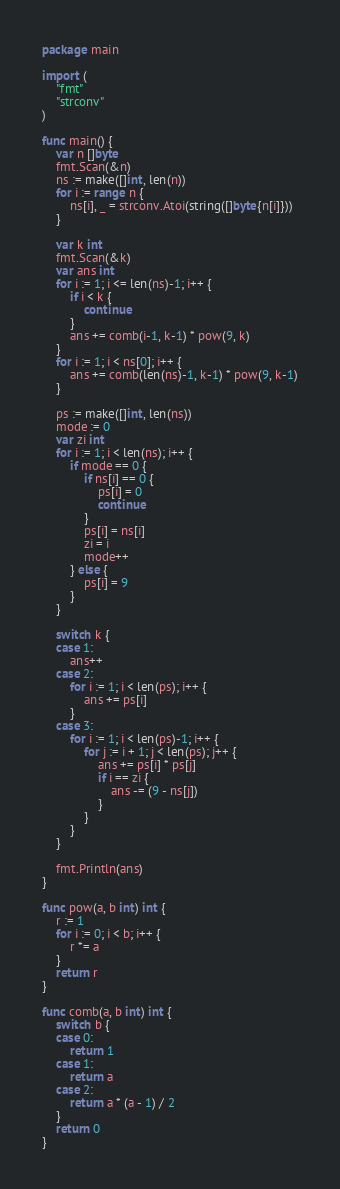Convert code to text. <code><loc_0><loc_0><loc_500><loc_500><_Go_>package main

import (
	"fmt"
	"strconv"
)

func main() {
	var n []byte
	fmt.Scan(&n)
	ns := make([]int, len(n))
	for i := range n {
		ns[i], _ = strconv.Atoi(string([]byte{n[i]}))
	}

	var k int
	fmt.Scan(&k)
	var ans int
	for i := 1; i <= len(ns)-1; i++ {
		if i < k {
			continue
		}
		ans += comb(i-1, k-1) * pow(9, k)
	}
	for i := 1; i < ns[0]; i++ {
		ans += comb(len(ns)-1, k-1) * pow(9, k-1)
	}

	ps := make([]int, len(ns))
	mode := 0
	var zi int
	for i := 1; i < len(ns); i++ {
		if mode == 0 {
			if ns[i] == 0 {
				ps[i] = 0
				continue
			}
			ps[i] = ns[i]
			zi = i
			mode++
		} else {
			ps[i] = 9
		}
	}

	switch k {
	case 1:
		ans++
	case 2:
		for i := 1; i < len(ps); i++ {
			ans += ps[i]
		}
	case 3:
		for i := 1; i < len(ps)-1; i++ {
			for j := i + 1; j < len(ps); j++ {
				ans += ps[i] * ps[j]
				if i == zi {
					ans -= (9 - ns[j])
				}
			}
		}
	}

	fmt.Println(ans)
}

func pow(a, b int) int {
	r := 1
	for i := 0; i < b; i++ {
		r *= a
	}
	return r
}

func comb(a, b int) int {
	switch b {
	case 0:
		return 1
	case 1:
		return a
	case 2:
		return a * (a - 1) / 2
	}
	return 0
}
</code> 